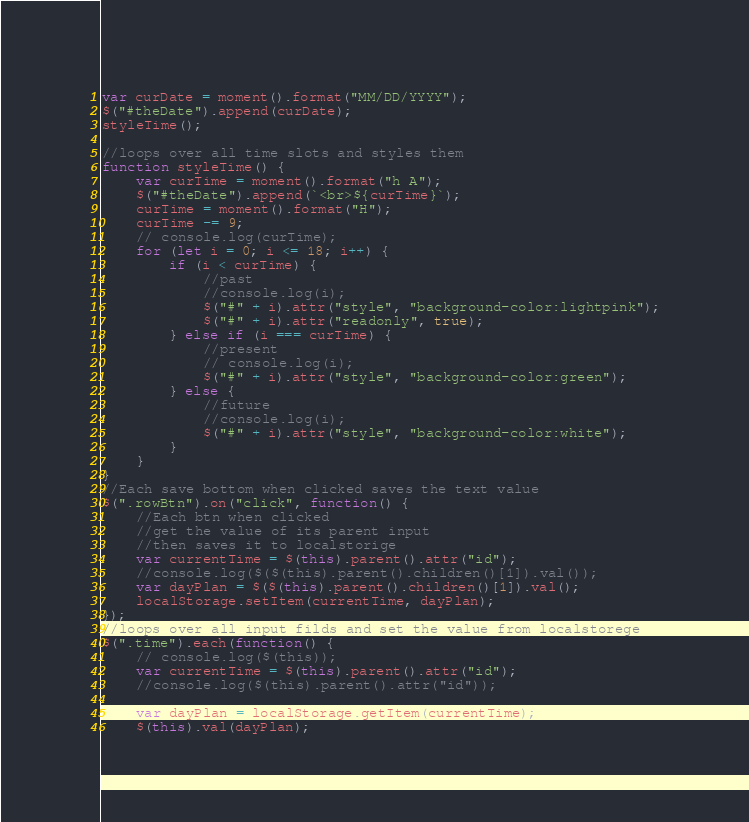<code> <loc_0><loc_0><loc_500><loc_500><_JavaScript_>var curDate = moment().format("MM/DD/YYYY");
$("#theDate").append(curDate);
styleTime();

//loops over all time slots and styles them
function styleTime() {
    var curTime = moment().format("h A");
    $("#theDate").append(`<br>${curTime}`);
    curTime = moment().format("H");
    curTime -= 9;
    // console.log(curTime);
    for (let i = 0; i <= 18; i++) {
        if (i < curTime) {
            //past
            //console.log(i);
            $("#" + i).attr("style", "background-color:lightpink");
            $("#" + i).attr("readonly", true);
        } else if (i === curTime) {
            //present
            // console.log(i);
            $("#" + i).attr("style", "background-color:green");
        } else {
            //future
            //console.log(i);
            $("#" + i).attr("style", "background-color:white");
        }
    }
}
//Each save bottom when clicked saves the text value
$(".rowBtn").on("click", function() {
    //Each btn when clicked
    //get the value of its parent input
    //then saves it to localstorige
    var currentTime = $(this).parent().attr("id");
    //console.log($($(this).parent().children()[1]).val());
    var dayPlan = $($(this).parent().children()[1]).val();
    localStorage.setItem(currentTime, dayPlan);
});
//loops over all input filds and set the value from localstorege
$(".time").each(function() {
    // console.log($(this));
    var currentTime = $(this).parent().attr("id");
    //console.log($(this).parent().attr("id"));

    var dayPlan = localStorage.getItem(currentTime);
    $(this).val(dayPlan);</code> 